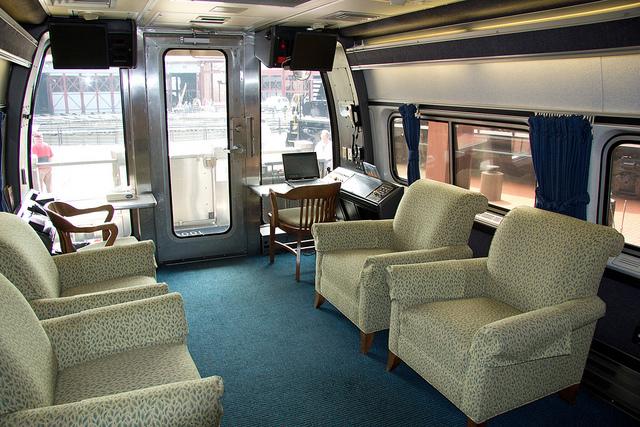How many chairs are there?
Be succinct. 6. Why is there extra cloth on the armchairs?
Quick response, please. To keep it clean. Is there enough room under the armchairs for a cat to hide?
Give a very brief answer. Yes. 